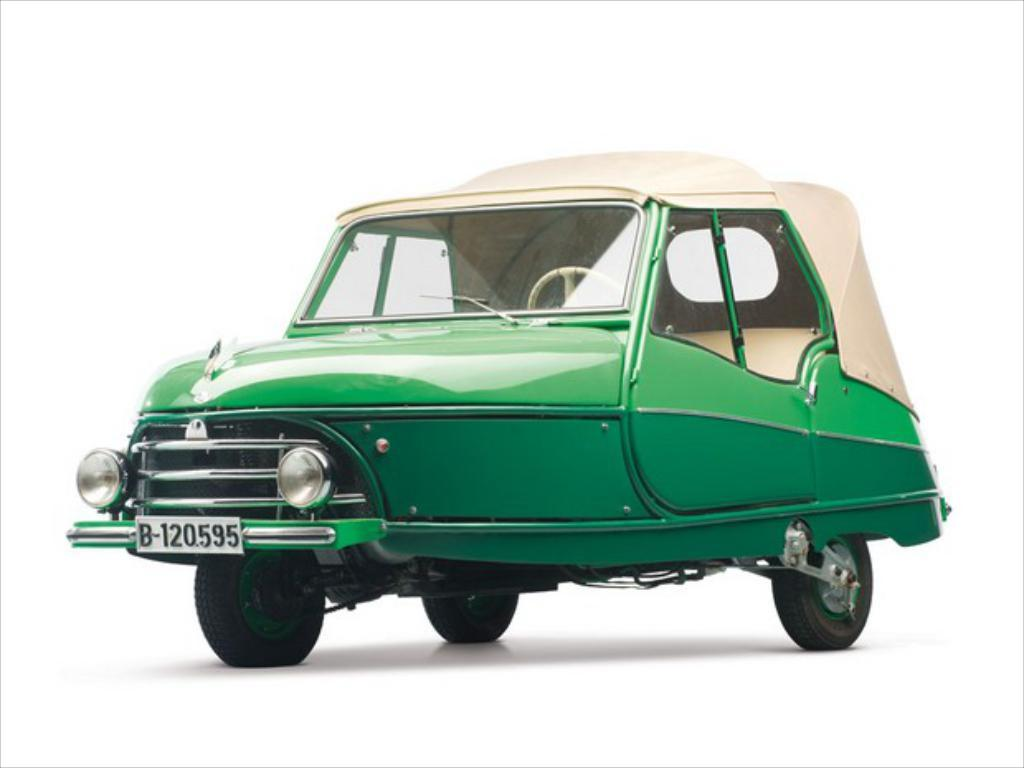Where was the image most likely taken? The image was likely taken indoors. What type of vehicle is visible in the image? There is a green car in the image. How is the car positioned in the image? The car is parked on a white surface, possibly the ground. What color is the background of the image? The background of the image is white in color. How many people are in the crowd surrounding the gold statue in the image? There is no crowd or gold statue present in the image. 